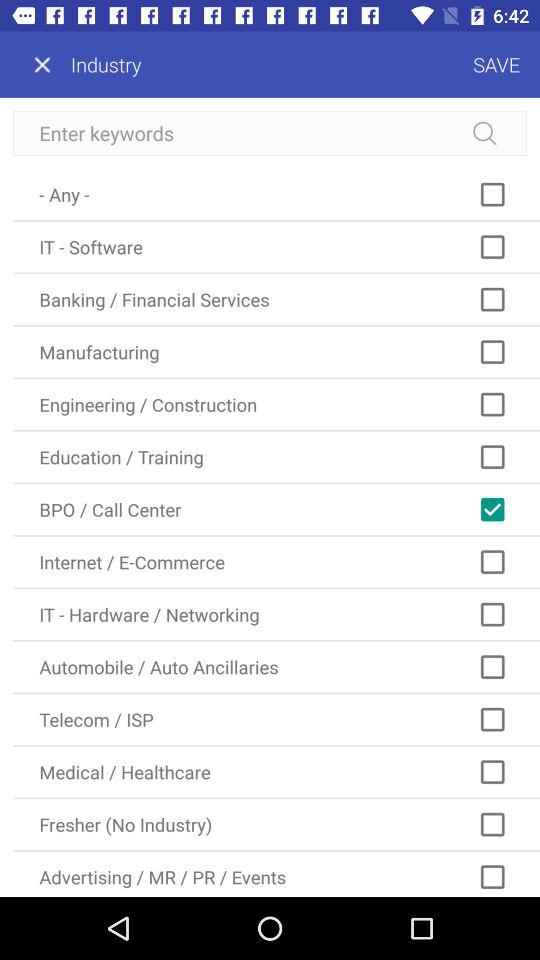What is the status of the "IT - Software"? The status of the "IT - Software" is "off". 